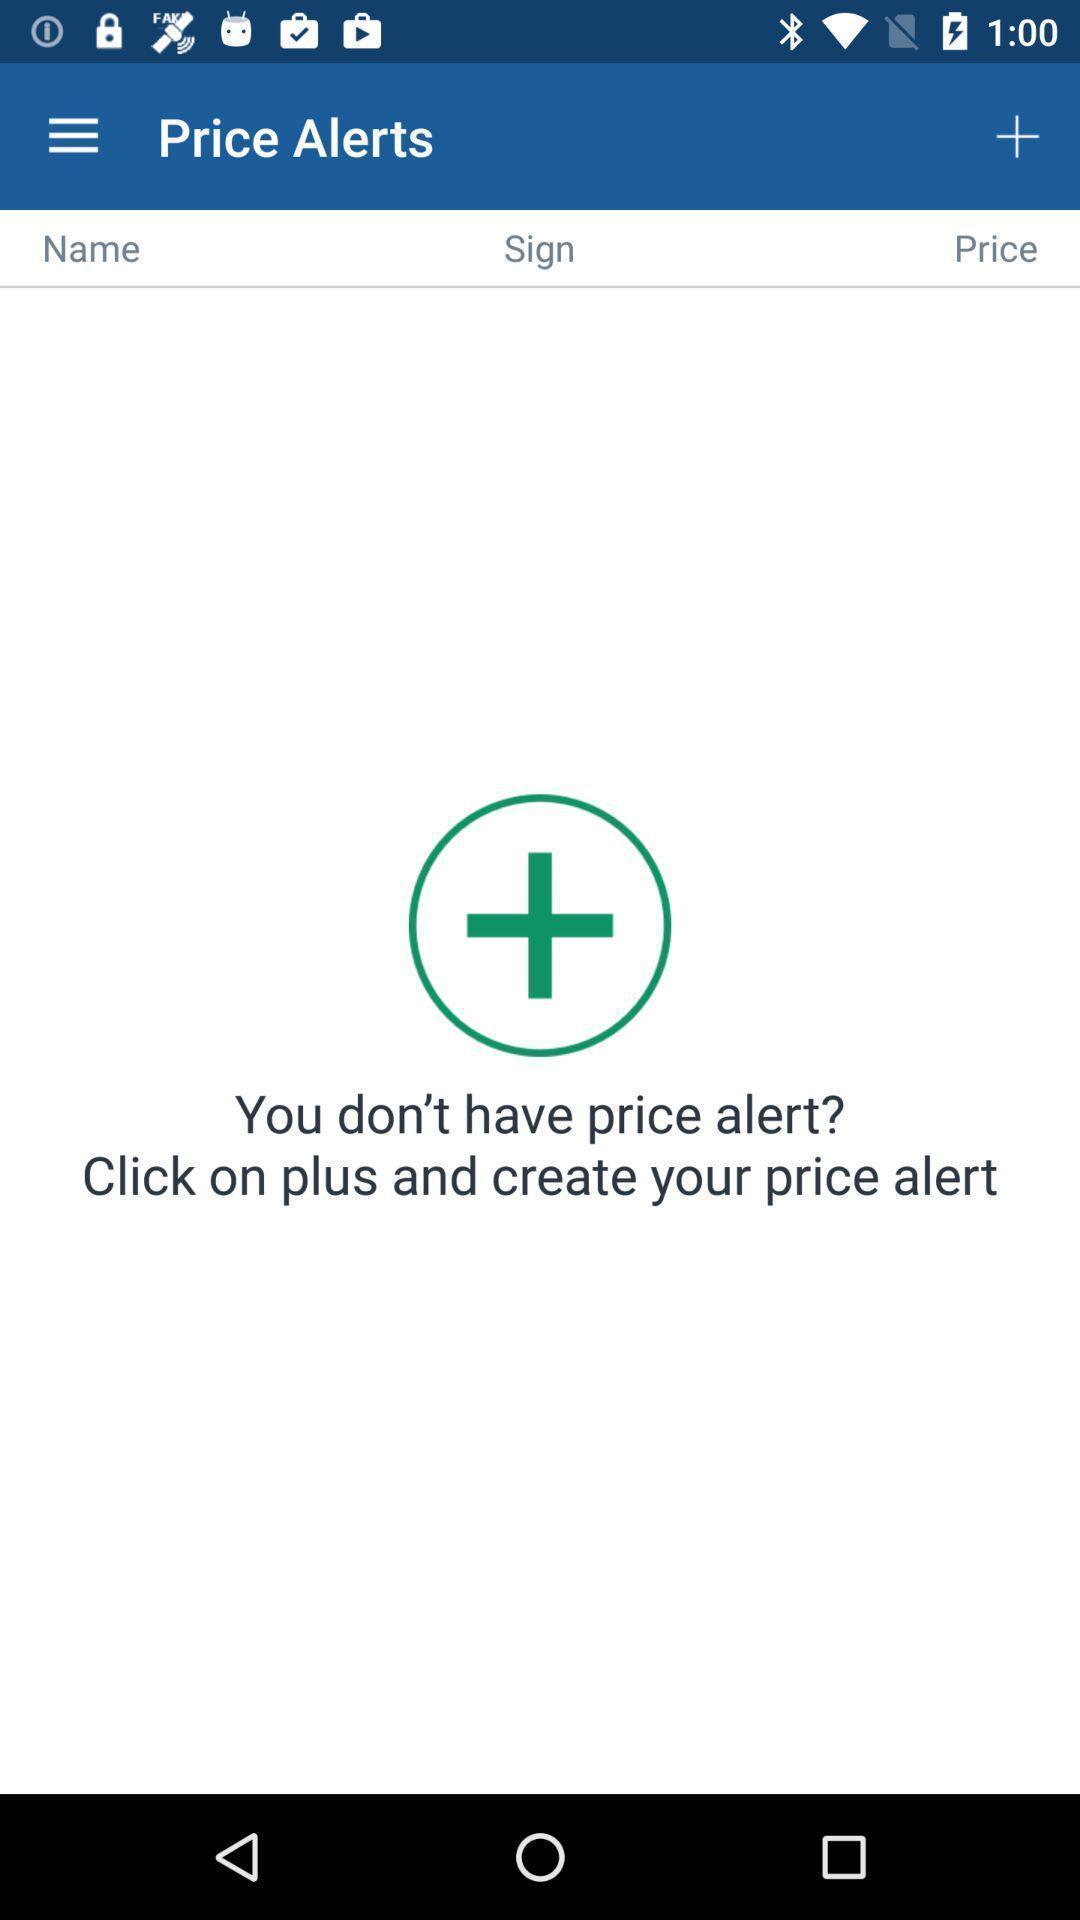Please provide a description for this image. Screen showing price alerts on an android application. 